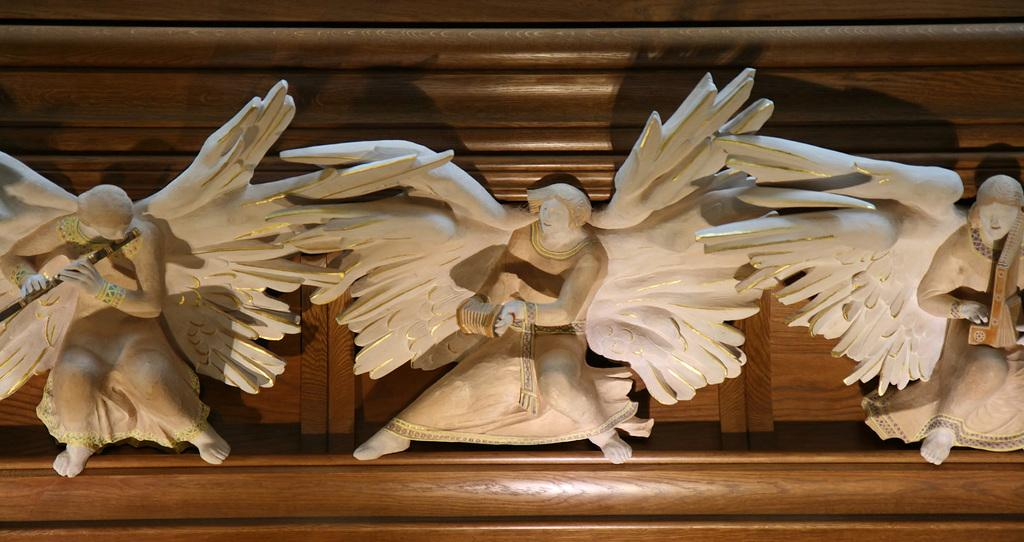What can be seen in the image? There are statues in the image. What are the statues placed on? The statues are on a wooden object. What type of basket is being used to carry the statues in the image? There is no basket present in the image; the statues are on a wooden object. 